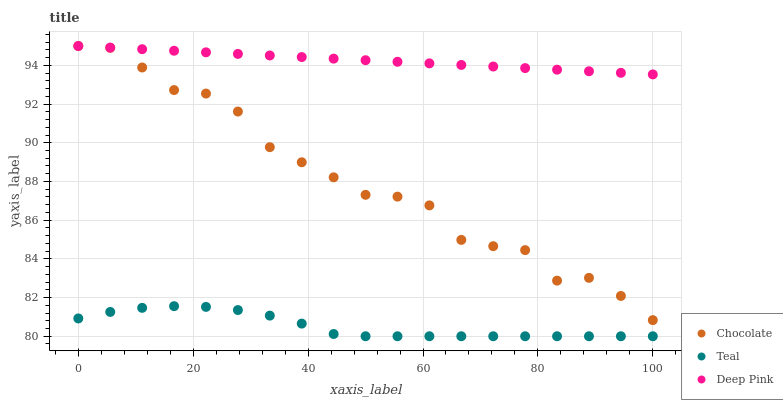Does Teal have the minimum area under the curve?
Answer yes or no. Yes. Does Deep Pink have the maximum area under the curve?
Answer yes or no. Yes. Does Chocolate have the minimum area under the curve?
Answer yes or no. No. Does Chocolate have the maximum area under the curve?
Answer yes or no. No. Is Deep Pink the smoothest?
Answer yes or no. Yes. Is Chocolate the roughest?
Answer yes or no. Yes. Is Teal the smoothest?
Answer yes or no. No. Is Teal the roughest?
Answer yes or no. No. Does Teal have the lowest value?
Answer yes or no. Yes. Does Chocolate have the lowest value?
Answer yes or no. No. Does Chocolate have the highest value?
Answer yes or no. Yes. Does Teal have the highest value?
Answer yes or no. No. Is Teal less than Deep Pink?
Answer yes or no. Yes. Is Deep Pink greater than Teal?
Answer yes or no. Yes. Does Deep Pink intersect Chocolate?
Answer yes or no. Yes. Is Deep Pink less than Chocolate?
Answer yes or no. No. Is Deep Pink greater than Chocolate?
Answer yes or no. No. Does Teal intersect Deep Pink?
Answer yes or no. No. 